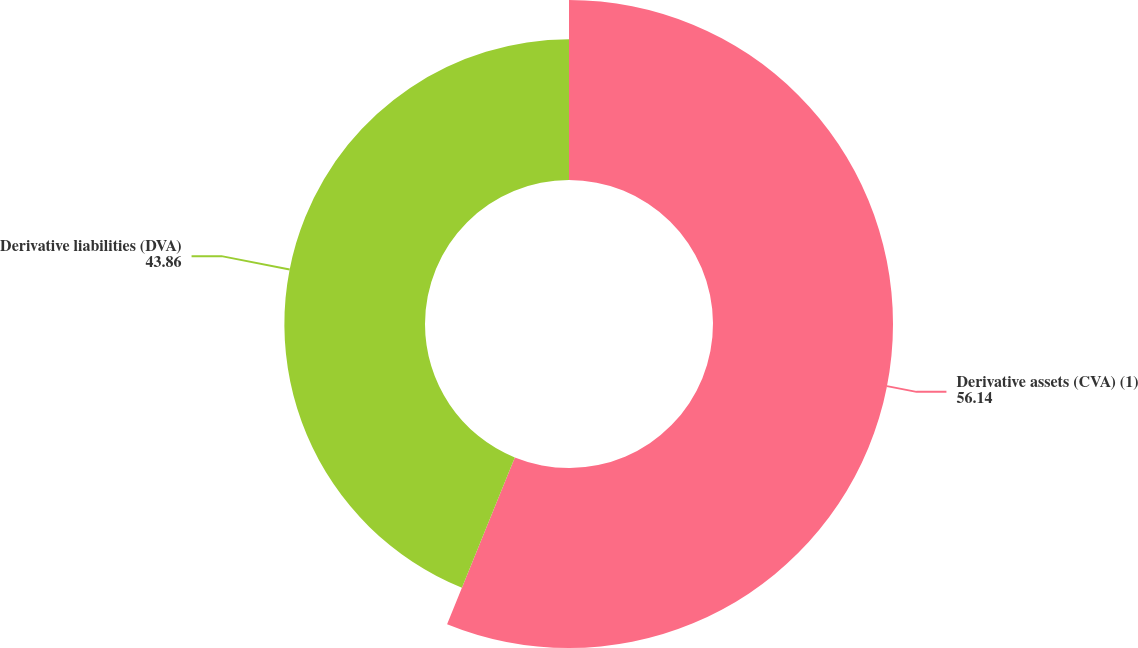Convert chart. <chart><loc_0><loc_0><loc_500><loc_500><pie_chart><fcel>Derivative assets (CVA) (1)<fcel>Derivative liabilities (DVA)<nl><fcel>56.14%<fcel>43.86%<nl></chart> 